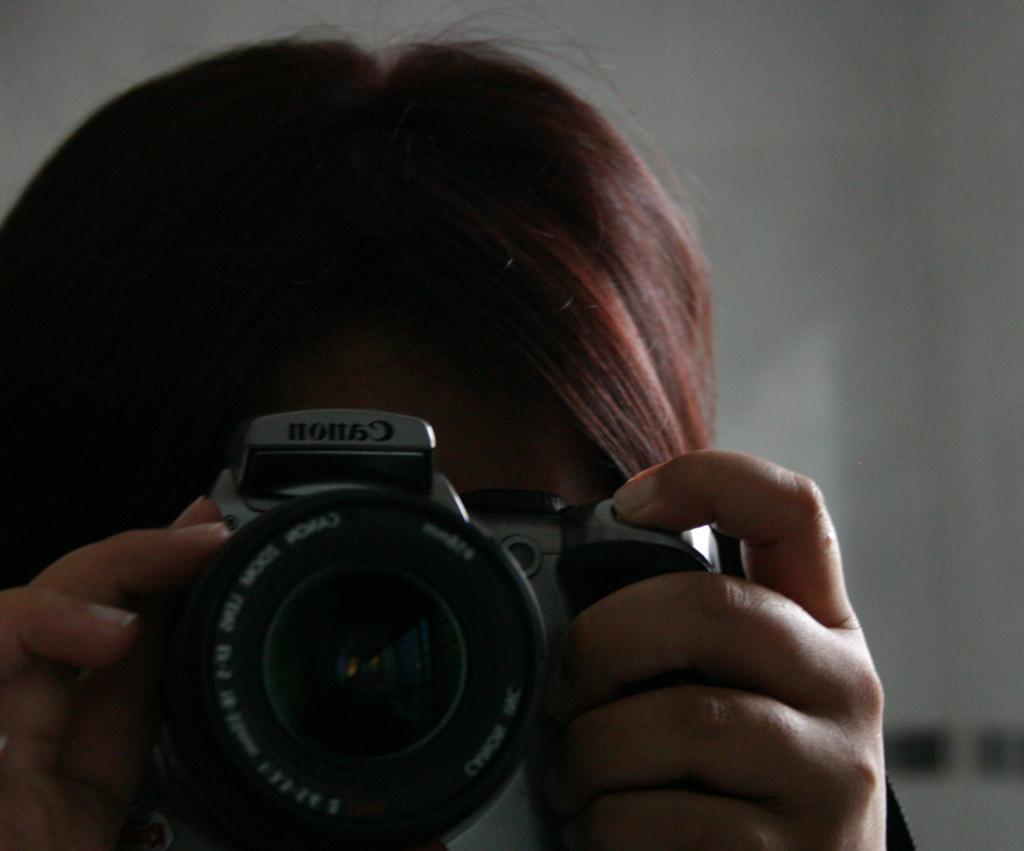Please provide a concise description of this image. In this image there is a person clicking a picture by holding a camera , and at the back ground there is a wall. 